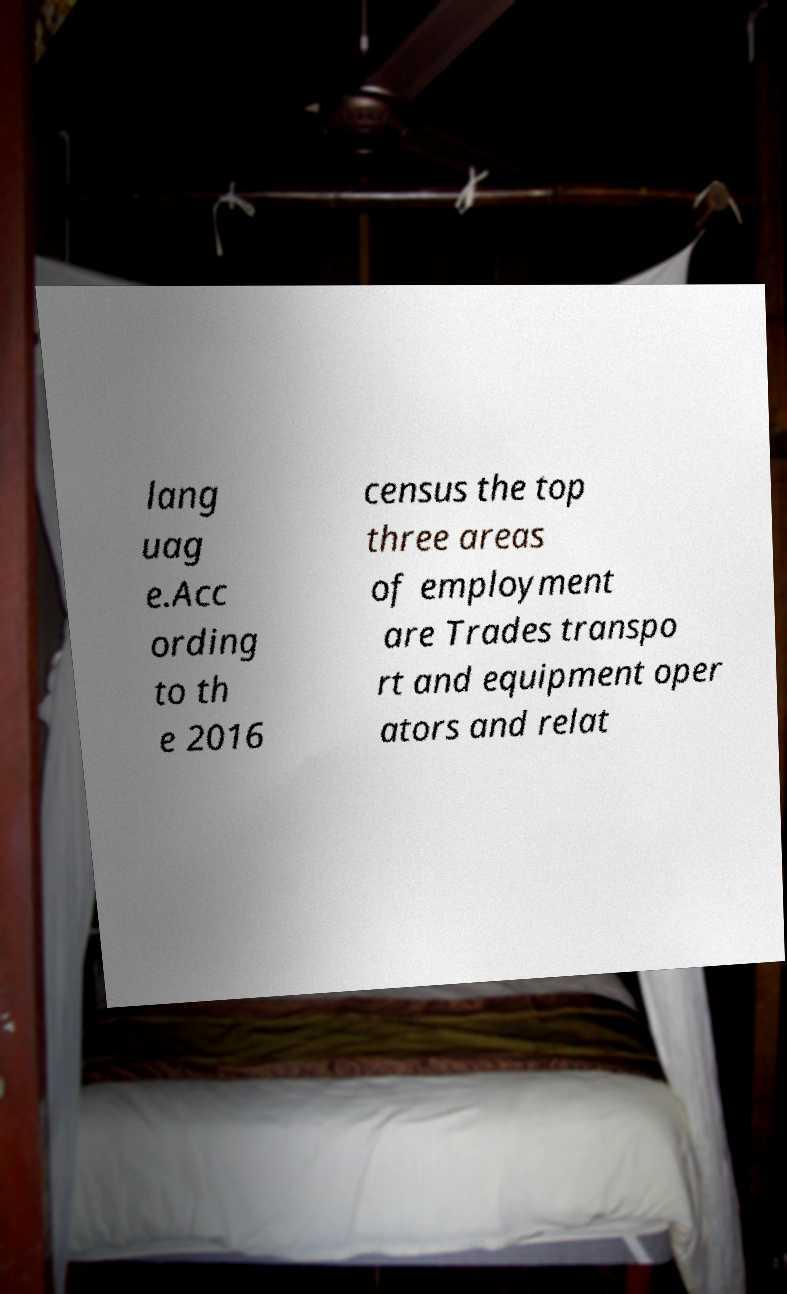There's text embedded in this image that I need extracted. Can you transcribe it verbatim? lang uag e.Acc ording to th e 2016 census the top three areas of employment are Trades transpo rt and equipment oper ators and relat 